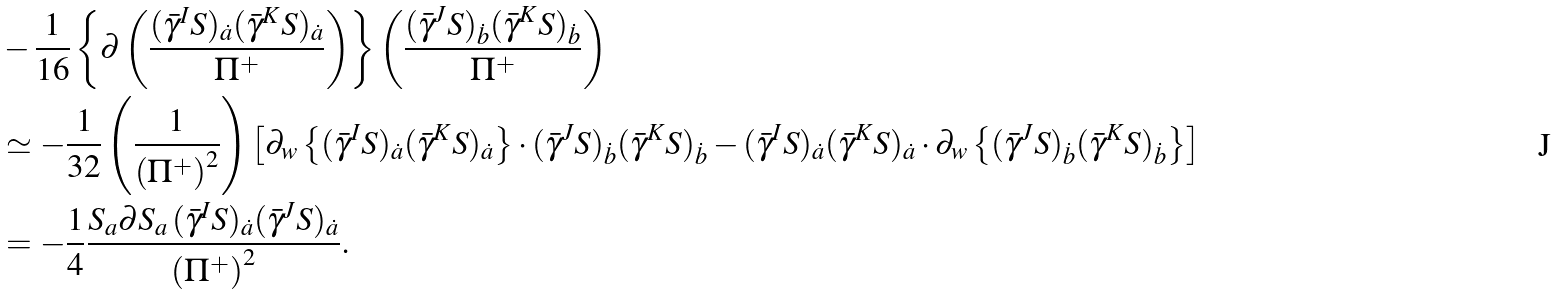Convert formula to latex. <formula><loc_0><loc_0><loc_500><loc_500>& - \frac { 1 } { 1 6 } \left \{ \partial \left ( \frac { ( \bar { \gamma } ^ { I } S ) _ { \dot { a } } ( \bar { \gamma } ^ { K } S ) _ { \dot { a } } } { \Pi ^ { + } } \right ) \right \} \left ( \frac { ( \bar { \gamma } ^ { J } S ) _ { \dot { b } } ( \bar { \gamma } ^ { K } S ) _ { \dot { b } } } { \Pi ^ { + } } \right ) \\ & \simeq - \frac { 1 } { 3 2 } \left ( \frac { 1 } { \left ( \Pi ^ { + } \right ) ^ { 2 } } \right ) \left [ \partial _ { w } \left \{ ( \bar { \gamma } ^ { I } S ) _ { \dot { a } } ( \bar { \gamma } ^ { K } S ) _ { \dot { a } } \right \} \cdot ( \bar { \gamma } ^ { J } S ) _ { \dot { b } } ( \bar { \gamma } ^ { K } S ) _ { \dot { b } } - ( \bar { \gamma } ^ { I } S ) _ { \dot { a } } ( \bar { \gamma } ^ { K } S ) _ { \dot { a } } \cdot \partial _ { w } \left \{ ( \bar { \gamma } ^ { J } S ) _ { \dot { b } } ( \bar { \gamma } ^ { K } S ) _ { \dot { b } } \right \} \right ] \\ & = - \frac { 1 } { 4 } \frac { S _ { a } \partial S _ { a } \, ( \bar { \gamma } ^ { I } S ) _ { \dot { a } } ( \bar { \gamma } ^ { J } S ) _ { \dot { a } } } { \left ( \Pi ^ { + } \right ) ^ { 2 } } .</formula> 